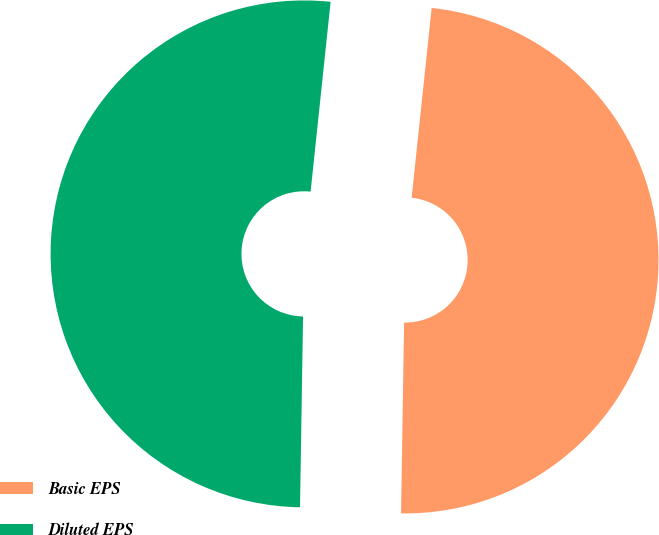Convert chart. <chart><loc_0><loc_0><loc_500><loc_500><pie_chart><fcel>Basic EPS<fcel>Diluted EPS<nl><fcel>48.58%<fcel>51.42%<nl></chart> 